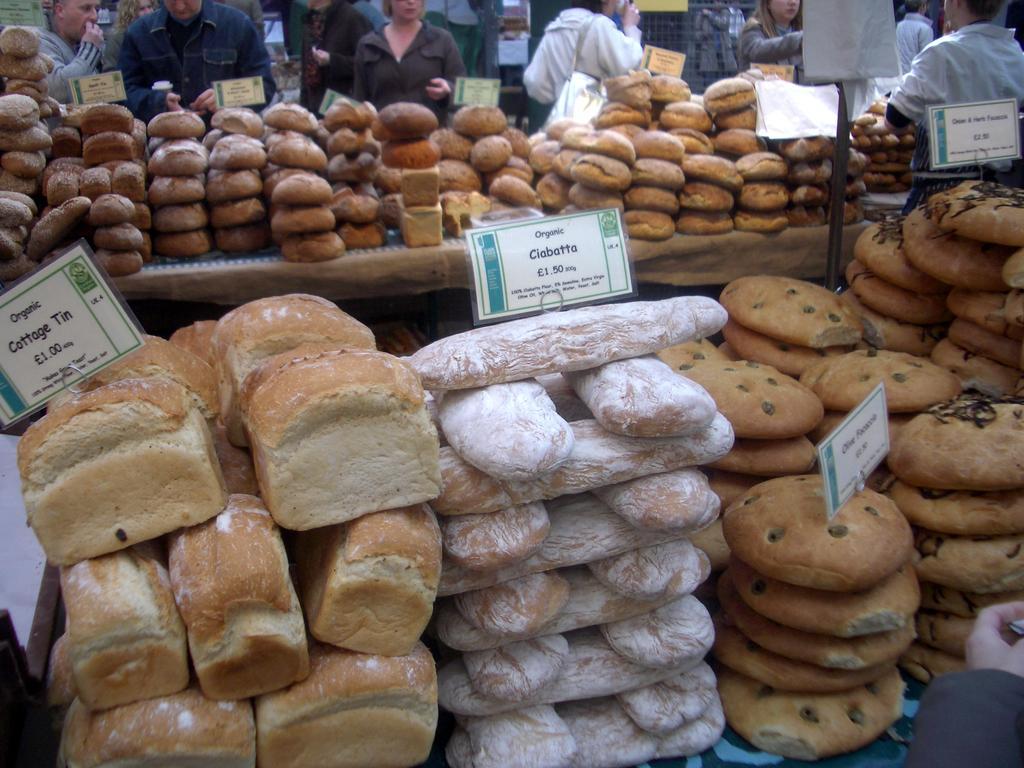Could you give a brief overview of what you see in this image? In this image I can see few food items in brown and white color. I can see few boards and few people around and they are wearing different color dresses. 